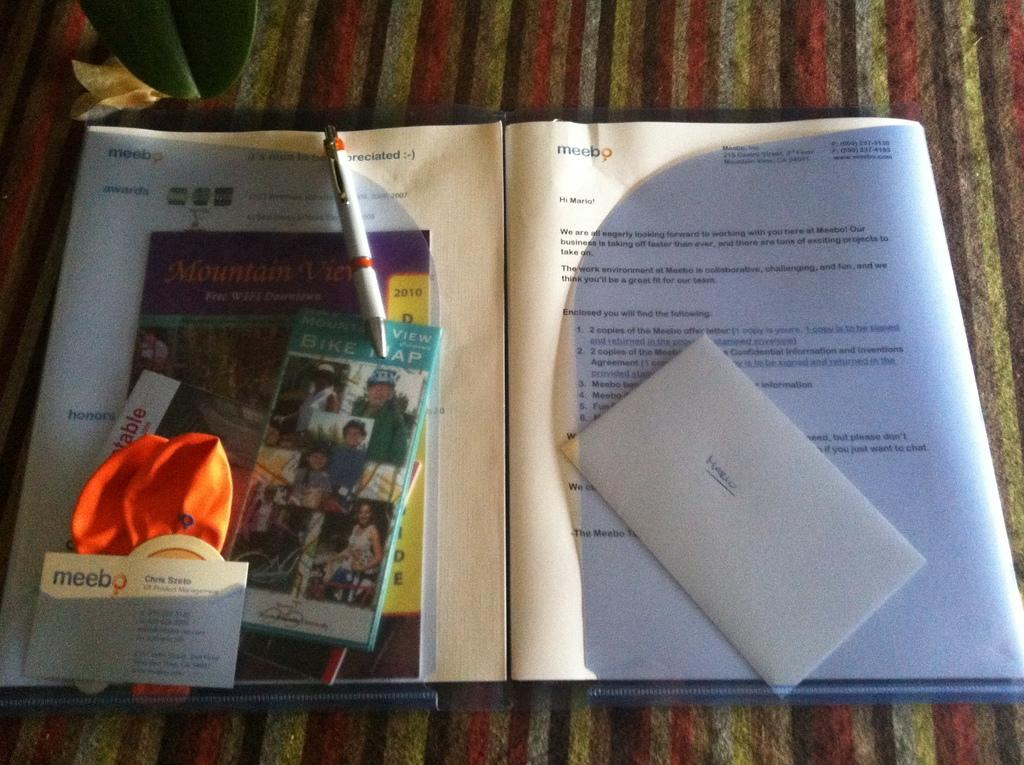Provide a one-sentence caption for the provided image. On the right side of an open folder, there is an envelope with the name Mario on it. 